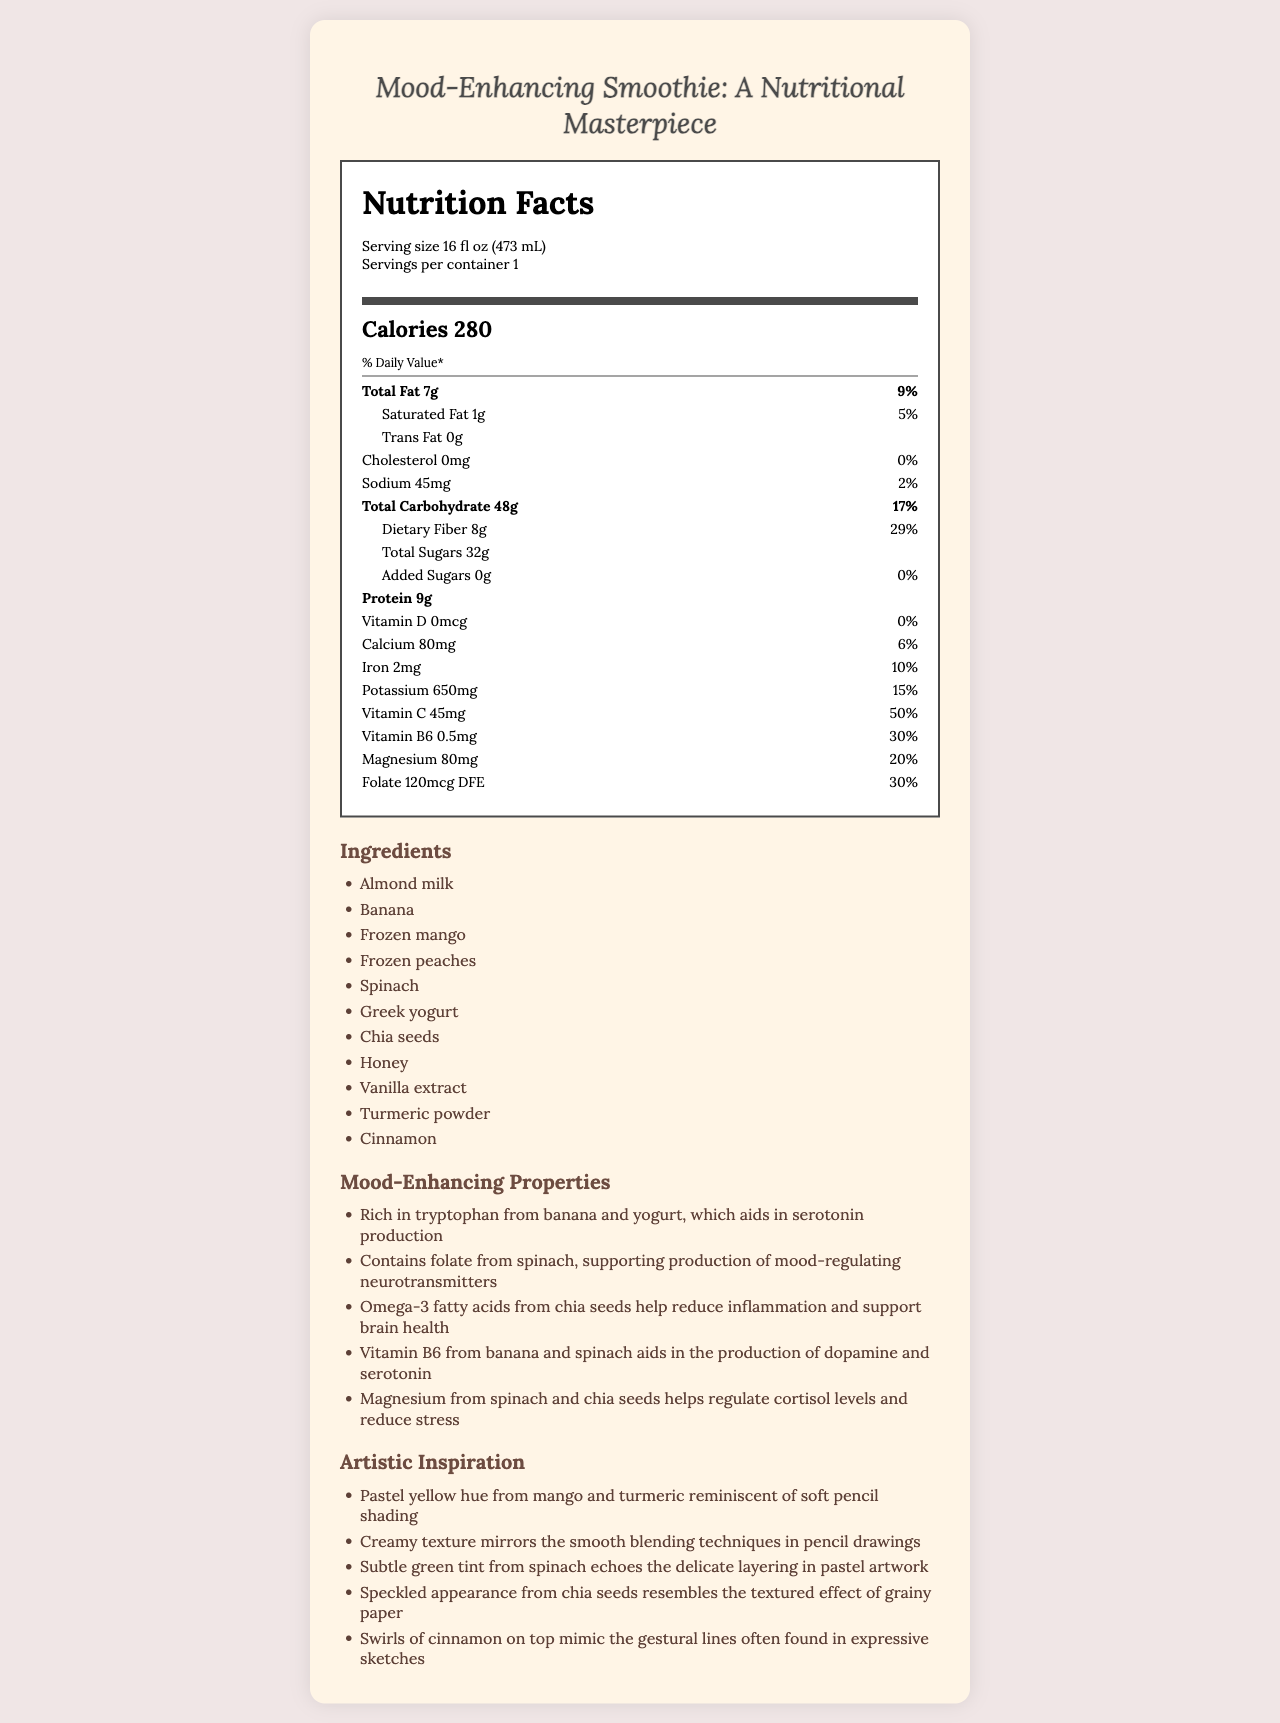what is the serving size of the smoothie? The serving size is listed at the top of the Nutrition Facts section as "Serving size 16 fl oz (473 mL)".
Answer: 16 fl oz (473 mL) how many calories are in one serving of the smoothie? The calorie content is displayed as "Calories 280" in the Nutrition Facts section.
Answer: 280 what amount of vitamin C does the smoothie provide per serving? The vitamin C content is listed as "Vitamin C 45mg" in the document.
Answer: 45mg how much total fat is in the smoothie, and what percentage of the daily value does it represent? The total fat content is noted as "Total Fat 7g" and corresponds to "9%" of the daily value.
Answer: 7g, 9% what are the primary ingredients in the smoothie? The ingredients are listed in the Ingredients section.
Answer: Almond milk, Banana, Frozen mango, Frozen peaches, Spinach, Greek yogurt, Chia seeds, Honey, Vanilla extract, Turmeric powder, Cinnamon which of the following nutrients is not present in the smoothie? A. Vitamin D B. Calcium C. Iron D. Potassium The nutrient list shows "Vitamin D 0mcg 0%" indicating it is not present, while other nutrients like Calcium, Iron, and Potassium are present.
Answer: A. Vitamin D how much protein does the smoothie contain? The protein content is displayed as "Protein 9g" in the Nutrition Facts section.
Answer: 9g what percentage of the daily value does the dietary fiber content represent? The dietary fiber content shows "8g" and "29%" in parentheses.
Answer: 29% does the smoothie contain any added sugars? The document states "Added Sugars 0g 0%", indicating there are no added sugars.
Answer: No how many milligrams of iron does the smoothie provide? The iron content is specified as "Iron 2mg 10%" in the document.
Answer: 2mg what mood-enhancing property is contributed by omega-3 fatty acids from chia seeds? The mood-enhancing properties section lists the benefits of omega-3 fatty acids from chia seeds.
Answer: Helps reduce inflammation and support brain health which vitamin aids in the production of dopamine and serotonin according to the document? The mood-enhancing properties mention that Vitamin B6 from banana and spinach aids in the production of dopamine and serotonin.
Answer: Vitamin B6 describe the artistic inspiration behind the smoothie. The Artistic Inspiration section details several visual and textural elements that draw parallels to traditional or pastel-inspired artwork.
Answer: The artistic inspiration of the smoothie includes pastel yellow hues from mango and turmeric, creamy texture mirroring smooth blending techniques, subtle green tint from spinach, speckled appearance from chia seeds, and swirls of cinnamon mimicking gestural lines in sketches. what is the document primarily about? The document can be summarized as detailing the nutritional facts, ingredients, mood-enhancing properties, and artistic inspiration of a mood-enhancing smoothie.
Answer: The document provides the nutritional content, ingredients, mood-enhancing properties, and artistic inspiration behind a mood-enhancing smoothie. how many servings are in one container of the smoothie? The serving information states "Servings per container 1."
Answer: 1 what type of milk is used in the smoothie? The Ingredients section lists "Almond milk" as the first ingredient.
Answer: Almond milk what is the total carbohydrate content and its daily value percentage in the smoothie? The total carbohydrate content is noted as "Total Carbohydrate 48g" with a daily value of "17%."
Answer: 48g, 17% which of these options correctly reflects the magnesium content and its daily value percentage? A. 60mg, 15% B. 70mg, 18% C. 80mg, 20% D. 90mg, 25% The document lists "Magnesium 80mg 20%" in the nutritional information.
Answer: C. 80mg, 20% what is the main characteristic of the smoothie that cannot be determined from the document? The document does not provide any information regarding the smoothie’s flavor.
Answer: Flavor is there any cholesterol in the smoothie? The document indicates "Cholesterol 0mg 0%" implying there is no cholesterol in the smoothie.
Answer: No 